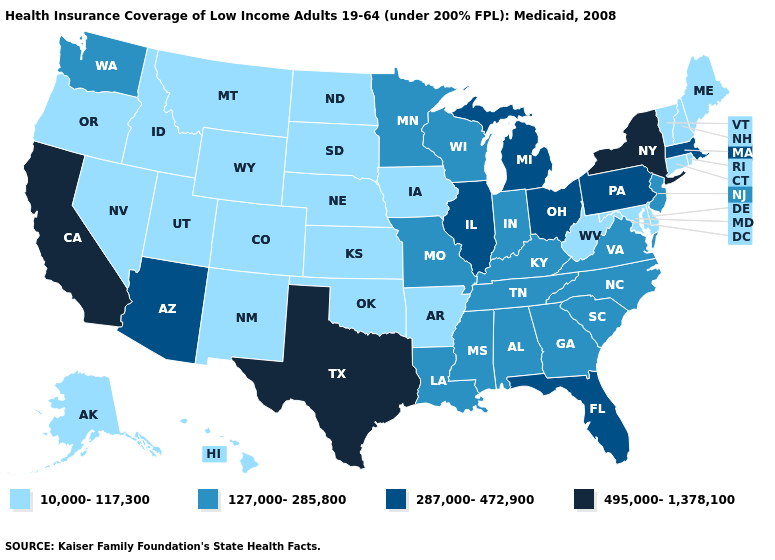What is the value of Arkansas?
Short answer required. 10,000-117,300. What is the value of Montana?
Concise answer only. 10,000-117,300. Does Washington have the lowest value in the West?
Write a very short answer. No. Among the states that border New Mexico , which have the lowest value?
Concise answer only. Colorado, Oklahoma, Utah. Does West Virginia have the same value as Michigan?
Be succinct. No. Among the states that border Maryland , does Virginia have the highest value?
Keep it brief. No. What is the value of New Jersey?
Quick response, please. 127,000-285,800. What is the highest value in the South ?
Give a very brief answer. 495,000-1,378,100. Does the map have missing data?
Keep it brief. No. Among the states that border Florida , which have the lowest value?
Short answer required. Alabama, Georgia. Name the states that have a value in the range 495,000-1,378,100?
Short answer required. California, New York, Texas. Name the states that have a value in the range 495,000-1,378,100?
Be succinct. California, New York, Texas. Which states hav the highest value in the South?
Be succinct. Texas. Name the states that have a value in the range 127,000-285,800?
Be succinct. Alabama, Georgia, Indiana, Kentucky, Louisiana, Minnesota, Mississippi, Missouri, New Jersey, North Carolina, South Carolina, Tennessee, Virginia, Washington, Wisconsin. Does Louisiana have the same value as Alabama?
Keep it brief. Yes. 